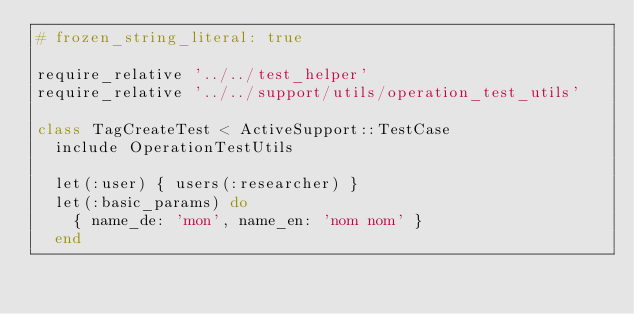<code> <loc_0><loc_0><loc_500><loc_500><_Ruby_># frozen_string_literal: true

require_relative '../../test_helper'
require_relative '../../support/utils/operation_test_utils'

class TagCreateTest < ActiveSupport::TestCase
  include OperationTestUtils

  let(:user) { users(:researcher) }
  let(:basic_params) do
    { name_de: 'mon', name_en: 'nom nom' }
  end
</code> 